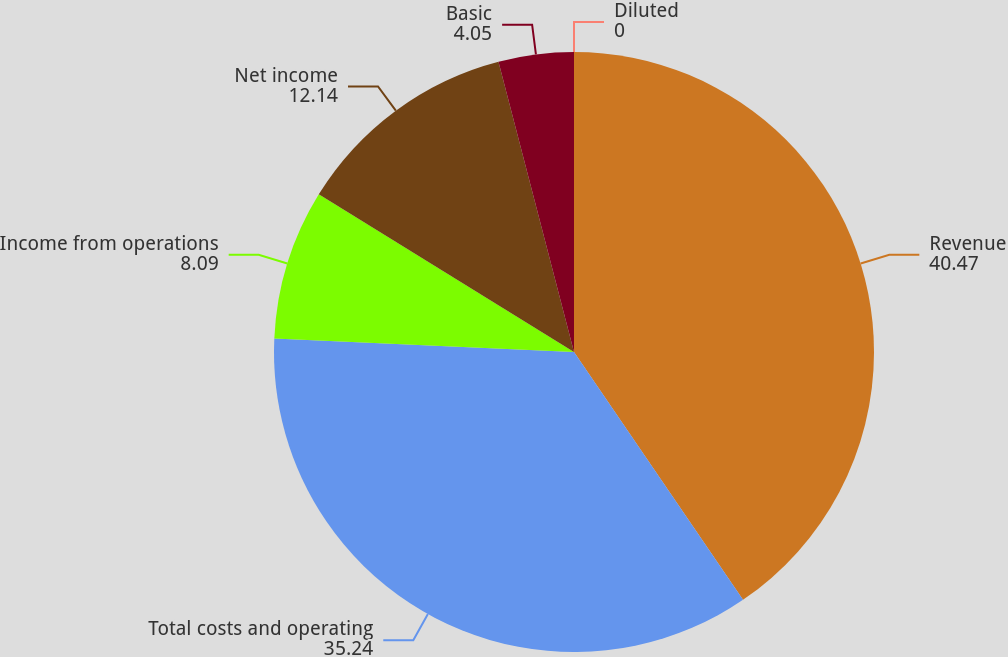<chart> <loc_0><loc_0><loc_500><loc_500><pie_chart><fcel>Revenue<fcel>Total costs and operating<fcel>Income from operations<fcel>Net income<fcel>Basic<fcel>Diluted<nl><fcel>40.47%<fcel>35.24%<fcel>8.09%<fcel>12.14%<fcel>4.05%<fcel>0.0%<nl></chart> 